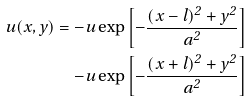<formula> <loc_0><loc_0><loc_500><loc_500>u ( x , y ) = - u \exp \left [ - \frac { ( x - l ) ^ { 2 } + y ^ { 2 } } { a ^ { 2 } } \right ] \\ - u \exp \left [ - \frac { ( x + l ) ^ { 2 } + y ^ { 2 } } { a ^ { 2 } } \right ]</formula> 